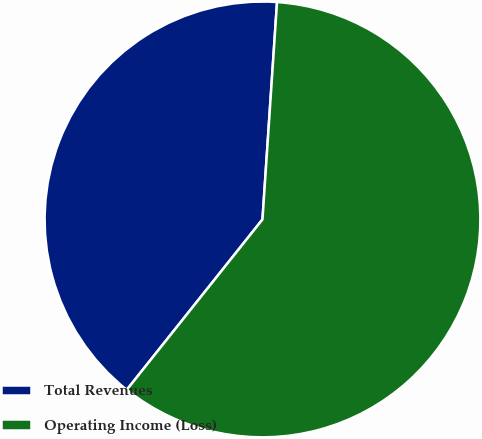Convert chart. <chart><loc_0><loc_0><loc_500><loc_500><pie_chart><fcel>Total Revenues<fcel>Operating Income (Loss)<nl><fcel>40.36%<fcel>59.64%<nl></chart> 